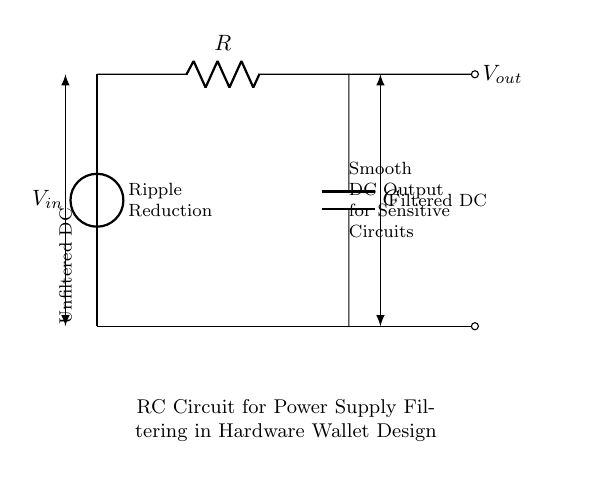What is the input voltage in the circuit? The input voltage is labeled as V_in in the circuit diagram, indicating the voltage source connected to the circuit.
Answer: V_in What components are present in this RC circuit? The circuit diagram includes a resistor (R) and a capacitor (C), which are the two essential components that form the RC circuit.
Answer: Resistor and Capacitor What is the purpose of the capacitor in this circuit? The capacitor is used primarily for filtering out voltage fluctuations, thereby smoothing the output voltage for sensitive components connected downstream.
Answer: Smoothing output voltage How does the resistor affect the filtering process? The resistor controls the charge and discharge rate of the capacitor, influencing the time constant of the circuit which directly affects how quickly the capacitor can respond to changes in input voltage.
Answer: Controls charge and discharge rate What does the arrow on the output indicate? The arrow labeled as V_out signifies the point in the circuit where the filtered output voltage can be measured, indicating it is the output from the capacitor after filtering.
Answer: Filtered output voltage What design feature helps in reducing voltage ripple? The combination of the resistor and capacitor forms a low-pass filter, which inherently reduces voltage ripple by allowing only low-frequency signals to pass while attenuating higher-frequency noise.
Answer: Low-pass filter 